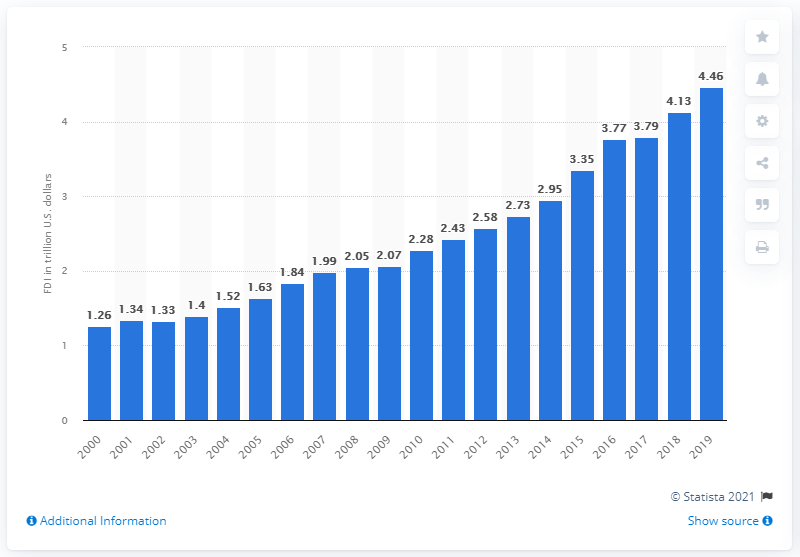Highlight a few significant elements in this photo. In 2000, the amount of foreign direct investment (FDI) in the United States was 1.26 trillion dollars. 